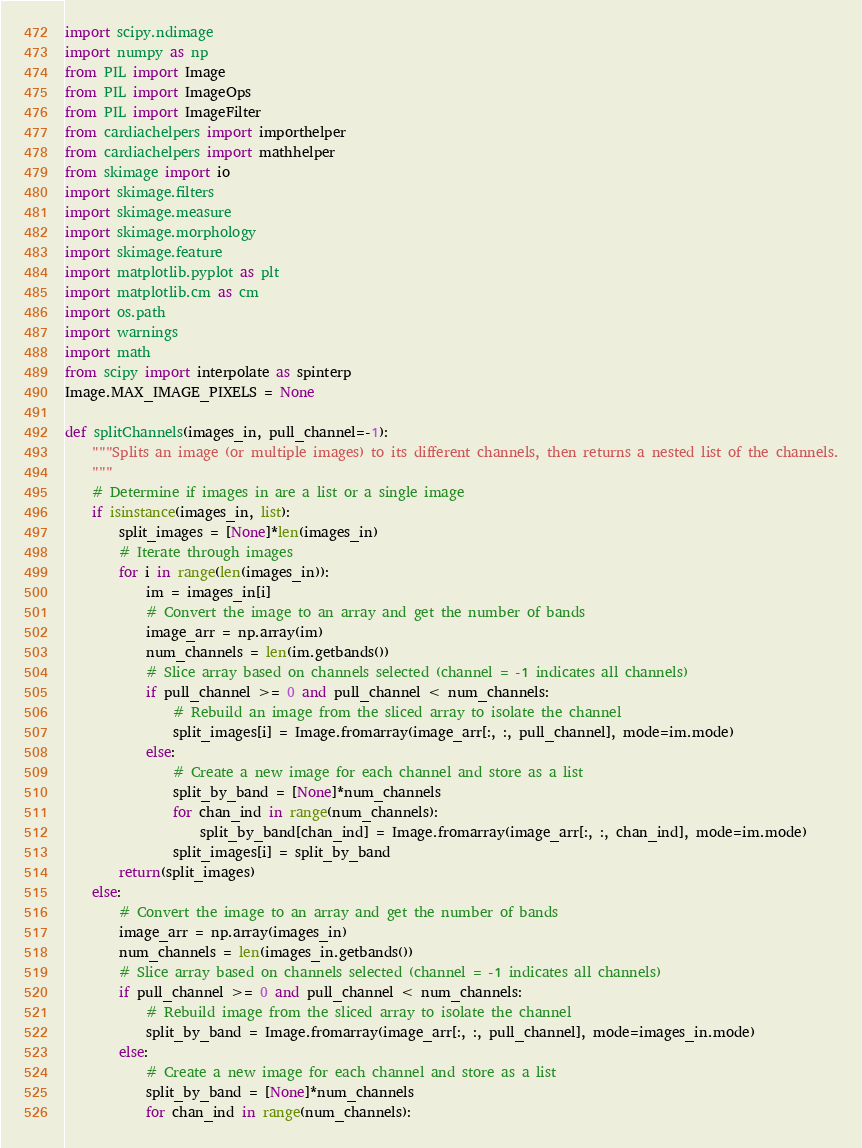Convert code to text. <code><loc_0><loc_0><loc_500><loc_500><_Python_>import scipy.ndimage
import numpy as np
from PIL import Image
from PIL import ImageOps
from PIL import ImageFilter
from cardiachelpers import importhelper
from cardiachelpers import mathhelper
from skimage import io
import skimage.filters
import skimage.measure
import skimage.morphology
import skimage.feature
import matplotlib.pyplot as plt
import matplotlib.cm as cm
import os.path
import warnings
import math
from scipy import interpolate as spinterp
Image.MAX_IMAGE_PIXELS = None

def splitChannels(images_in, pull_channel=-1):
	"""Splits an image (or multiple images) to its different channels, then returns a nested list of the channels.
	"""
	# Determine if images in are a list or a single image
	if isinstance(images_in, list):
		split_images = [None]*len(images_in)
		# Iterate through images
		for i in range(len(images_in)):
			im = images_in[i]
			# Convert the image to an array and get the number of bands
			image_arr = np.array(im)
			num_channels = len(im.getbands())
			# Slice array based on channels selected (channel = -1 indicates all channels)
			if pull_channel >= 0 and pull_channel < num_channels:
				# Rebuild an image from the sliced array to isolate the channel
				split_images[i] = Image.fromarray(image_arr[:, :, pull_channel], mode=im.mode)
			else:
				# Create a new image for each channel and store as a list
				split_by_band = [None]*num_channels
				for chan_ind in range(num_channels):
					split_by_band[chan_ind] = Image.fromarray(image_arr[:, :, chan_ind], mode=im.mode)
				split_images[i] = split_by_band
		return(split_images)
	else:
		# Convert the image to an array and get the number of bands
		image_arr = np.array(images_in)
		num_channels = len(images_in.getbands())
		# Slice array based on channels selected (channel = -1 indicates all channels)
		if pull_channel >= 0 and pull_channel < num_channels:
			# Rebuild image from the sliced array to isolate the channel
			split_by_band = Image.fromarray(image_arr[:, :, pull_channel], mode=images_in.mode)
		else:
			# Create a new image for each channel and store as a list
			split_by_band = [None]*num_channels
			for chan_ind in range(num_channels):</code> 